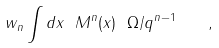<formula> <loc_0><loc_0><loc_500><loc_500>w _ { n } \int d x \ M ^ { n } ( x ) \ \Omega / q ^ { n - 1 } \quad ,</formula> 